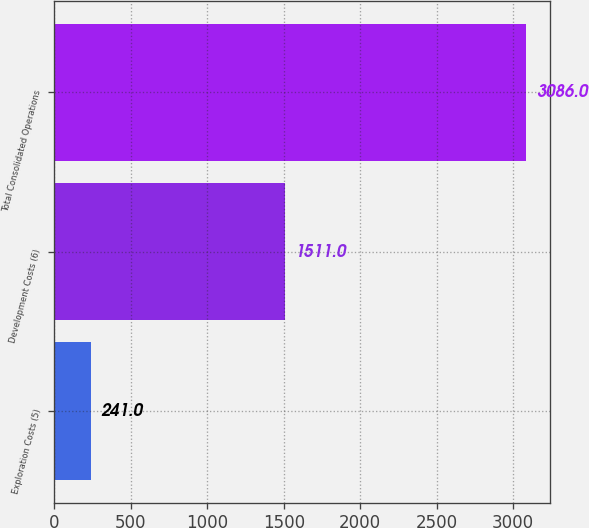<chart> <loc_0><loc_0><loc_500><loc_500><bar_chart><fcel>Exploration Costs (5)<fcel>Development Costs (6)<fcel>Total Consolidated Operations<nl><fcel>241<fcel>1511<fcel>3086<nl></chart> 